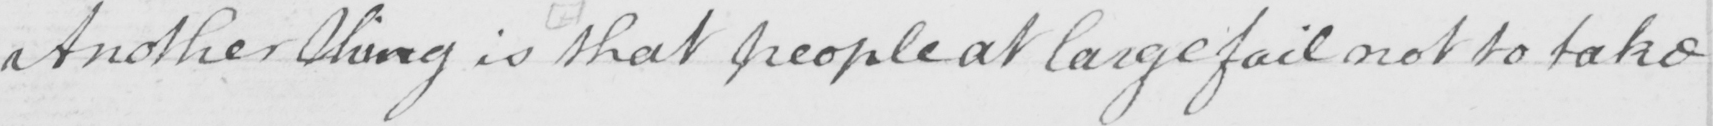Can you read and transcribe this handwriting? Another thing is that people at large fail not to take 